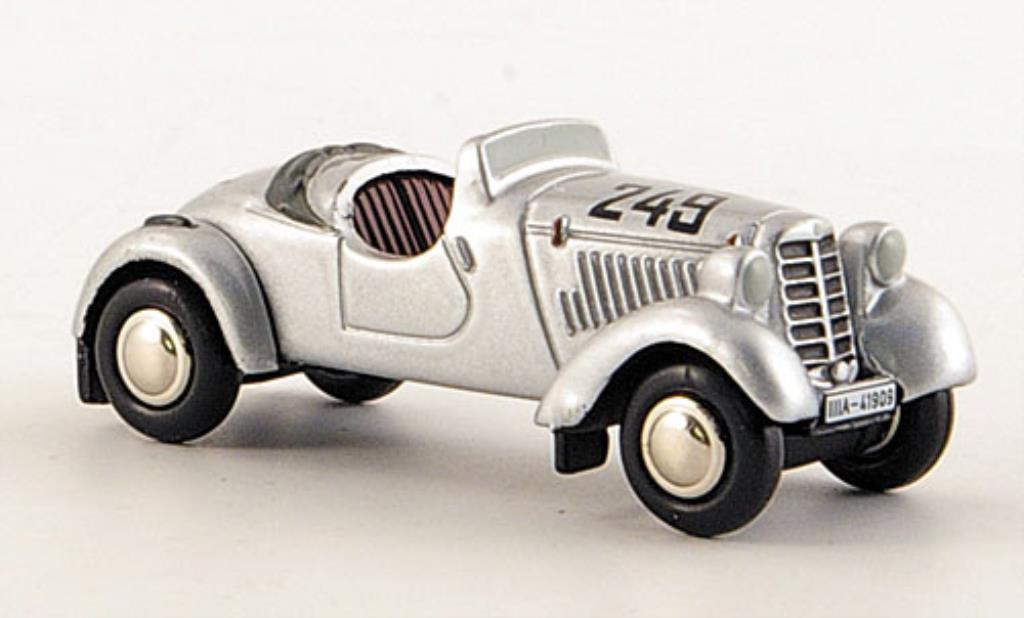If this car could talk, what stories might it share about its adventures? Ah, the tales I could spin! I've thundered down race tracks, my metal heart beating with the thrill of competition. I remember that one glorious race in 1935 where we, a fearless driver and I, defied the odds. The crowd's roar, the smell of fuel, the taste of victory still linger. I've felt the caress of the wind on my hood as we broke speed barriers and tasted the grit of the track under my rubber tires. Beyond the races, I've been part of clandestine midnight runs, carrying messages of utmost importance through shadowed roads. Each dent and scratch is a badge of honor, a story etched in steel and chrome. 